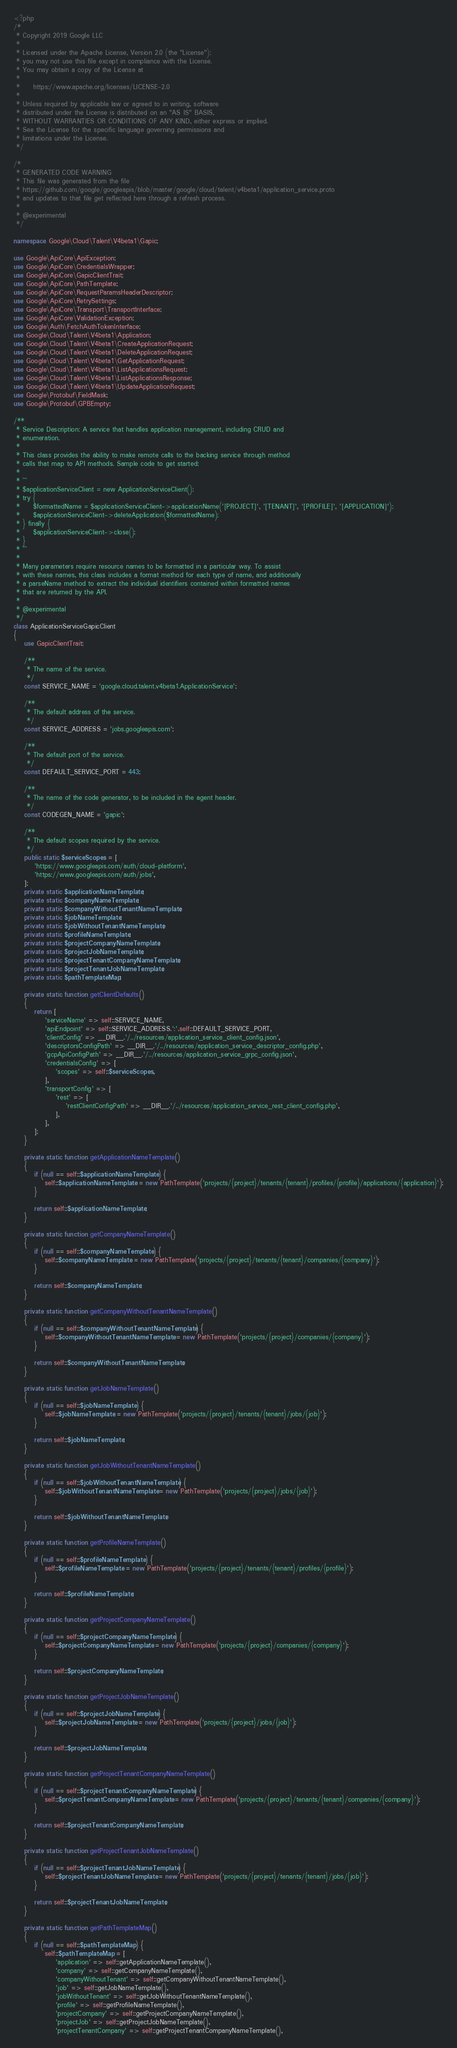<code> <loc_0><loc_0><loc_500><loc_500><_PHP_><?php
/*
 * Copyright 2019 Google LLC
 *
 * Licensed under the Apache License, Version 2.0 (the "License");
 * you may not use this file except in compliance with the License.
 * You may obtain a copy of the License at
 *
 *     https://www.apache.org/licenses/LICENSE-2.0
 *
 * Unless required by applicable law or agreed to in writing, software
 * distributed under the License is distributed on an "AS IS" BASIS,
 * WITHOUT WARRANTIES OR CONDITIONS OF ANY KIND, either express or implied.
 * See the License for the specific language governing permissions and
 * limitations under the License.
 */

/*
 * GENERATED CODE WARNING
 * This file was generated from the file
 * https://github.com/google/googleapis/blob/master/google/cloud/talent/v4beta1/application_service.proto
 * and updates to that file get reflected here through a refresh process.
 *
 * @experimental
 */

namespace Google\Cloud\Talent\V4beta1\Gapic;

use Google\ApiCore\ApiException;
use Google\ApiCore\CredentialsWrapper;
use Google\ApiCore\GapicClientTrait;
use Google\ApiCore\PathTemplate;
use Google\ApiCore\RequestParamsHeaderDescriptor;
use Google\ApiCore\RetrySettings;
use Google\ApiCore\Transport\TransportInterface;
use Google\ApiCore\ValidationException;
use Google\Auth\FetchAuthTokenInterface;
use Google\Cloud\Talent\V4beta1\Application;
use Google\Cloud\Talent\V4beta1\CreateApplicationRequest;
use Google\Cloud\Talent\V4beta1\DeleteApplicationRequest;
use Google\Cloud\Talent\V4beta1\GetApplicationRequest;
use Google\Cloud\Talent\V4beta1\ListApplicationsRequest;
use Google\Cloud\Talent\V4beta1\ListApplicationsResponse;
use Google\Cloud\Talent\V4beta1\UpdateApplicationRequest;
use Google\Protobuf\FieldMask;
use Google\Protobuf\GPBEmpty;

/**
 * Service Description: A service that handles application management, including CRUD and
 * enumeration.
 *
 * This class provides the ability to make remote calls to the backing service through method
 * calls that map to API methods. Sample code to get started:
 *
 * ```
 * $applicationServiceClient = new ApplicationServiceClient();
 * try {
 *     $formattedName = $applicationServiceClient->applicationName('[PROJECT]', '[TENANT]', '[PROFILE]', '[APPLICATION]');
 *     $applicationServiceClient->deleteApplication($formattedName);
 * } finally {
 *     $applicationServiceClient->close();
 * }
 * ```
 *
 * Many parameters require resource names to be formatted in a particular way. To assist
 * with these names, this class includes a format method for each type of name, and additionally
 * a parseName method to extract the individual identifiers contained within formatted names
 * that are returned by the API.
 *
 * @experimental
 */
class ApplicationServiceGapicClient
{
    use GapicClientTrait;

    /**
     * The name of the service.
     */
    const SERVICE_NAME = 'google.cloud.talent.v4beta1.ApplicationService';

    /**
     * The default address of the service.
     */
    const SERVICE_ADDRESS = 'jobs.googleapis.com';

    /**
     * The default port of the service.
     */
    const DEFAULT_SERVICE_PORT = 443;

    /**
     * The name of the code generator, to be included in the agent header.
     */
    const CODEGEN_NAME = 'gapic';

    /**
     * The default scopes required by the service.
     */
    public static $serviceScopes = [
        'https://www.googleapis.com/auth/cloud-platform',
        'https://www.googleapis.com/auth/jobs',
    ];
    private static $applicationNameTemplate;
    private static $companyNameTemplate;
    private static $companyWithoutTenantNameTemplate;
    private static $jobNameTemplate;
    private static $jobWithoutTenantNameTemplate;
    private static $profileNameTemplate;
    private static $projectCompanyNameTemplate;
    private static $projectJobNameTemplate;
    private static $projectTenantCompanyNameTemplate;
    private static $projectTenantJobNameTemplate;
    private static $pathTemplateMap;

    private static function getClientDefaults()
    {
        return [
            'serviceName' => self::SERVICE_NAME,
            'apiEndpoint' => self::SERVICE_ADDRESS.':'.self::DEFAULT_SERVICE_PORT,
            'clientConfig' => __DIR__.'/../resources/application_service_client_config.json',
            'descriptorsConfigPath' => __DIR__.'/../resources/application_service_descriptor_config.php',
            'gcpApiConfigPath' => __DIR__.'/../resources/application_service_grpc_config.json',
            'credentialsConfig' => [
                'scopes' => self::$serviceScopes,
            ],
            'transportConfig' => [
                'rest' => [
                    'restClientConfigPath' => __DIR__.'/../resources/application_service_rest_client_config.php',
                ],
            ],
        ];
    }

    private static function getApplicationNameTemplate()
    {
        if (null == self::$applicationNameTemplate) {
            self::$applicationNameTemplate = new PathTemplate('projects/{project}/tenants/{tenant}/profiles/{profile}/applications/{application}');
        }

        return self::$applicationNameTemplate;
    }

    private static function getCompanyNameTemplate()
    {
        if (null == self::$companyNameTemplate) {
            self::$companyNameTemplate = new PathTemplate('projects/{project}/tenants/{tenant}/companies/{company}');
        }

        return self::$companyNameTemplate;
    }

    private static function getCompanyWithoutTenantNameTemplate()
    {
        if (null == self::$companyWithoutTenantNameTemplate) {
            self::$companyWithoutTenantNameTemplate = new PathTemplate('projects/{project}/companies/{company}');
        }

        return self::$companyWithoutTenantNameTemplate;
    }

    private static function getJobNameTemplate()
    {
        if (null == self::$jobNameTemplate) {
            self::$jobNameTemplate = new PathTemplate('projects/{project}/tenants/{tenant}/jobs/{job}');
        }

        return self::$jobNameTemplate;
    }

    private static function getJobWithoutTenantNameTemplate()
    {
        if (null == self::$jobWithoutTenantNameTemplate) {
            self::$jobWithoutTenantNameTemplate = new PathTemplate('projects/{project}/jobs/{job}');
        }

        return self::$jobWithoutTenantNameTemplate;
    }

    private static function getProfileNameTemplate()
    {
        if (null == self::$profileNameTemplate) {
            self::$profileNameTemplate = new PathTemplate('projects/{project}/tenants/{tenant}/profiles/{profile}');
        }

        return self::$profileNameTemplate;
    }

    private static function getProjectCompanyNameTemplate()
    {
        if (null == self::$projectCompanyNameTemplate) {
            self::$projectCompanyNameTemplate = new PathTemplate('projects/{project}/companies/{company}');
        }

        return self::$projectCompanyNameTemplate;
    }

    private static function getProjectJobNameTemplate()
    {
        if (null == self::$projectJobNameTemplate) {
            self::$projectJobNameTemplate = new PathTemplate('projects/{project}/jobs/{job}');
        }

        return self::$projectJobNameTemplate;
    }

    private static function getProjectTenantCompanyNameTemplate()
    {
        if (null == self::$projectTenantCompanyNameTemplate) {
            self::$projectTenantCompanyNameTemplate = new PathTemplate('projects/{project}/tenants/{tenant}/companies/{company}');
        }

        return self::$projectTenantCompanyNameTemplate;
    }

    private static function getProjectTenantJobNameTemplate()
    {
        if (null == self::$projectTenantJobNameTemplate) {
            self::$projectTenantJobNameTemplate = new PathTemplate('projects/{project}/tenants/{tenant}/jobs/{job}');
        }

        return self::$projectTenantJobNameTemplate;
    }

    private static function getPathTemplateMap()
    {
        if (null == self::$pathTemplateMap) {
            self::$pathTemplateMap = [
                'application' => self::getApplicationNameTemplate(),
                'company' => self::getCompanyNameTemplate(),
                'companyWithoutTenant' => self::getCompanyWithoutTenantNameTemplate(),
                'job' => self::getJobNameTemplate(),
                'jobWithoutTenant' => self::getJobWithoutTenantNameTemplate(),
                'profile' => self::getProfileNameTemplate(),
                'projectCompany' => self::getProjectCompanyNameTemplate(),
                'projectJob' => self::getProjectJobNameTemplate(),
                'projectTenantCompany' => self::getProjectTenantCompanyNameTemplate(),</code> 